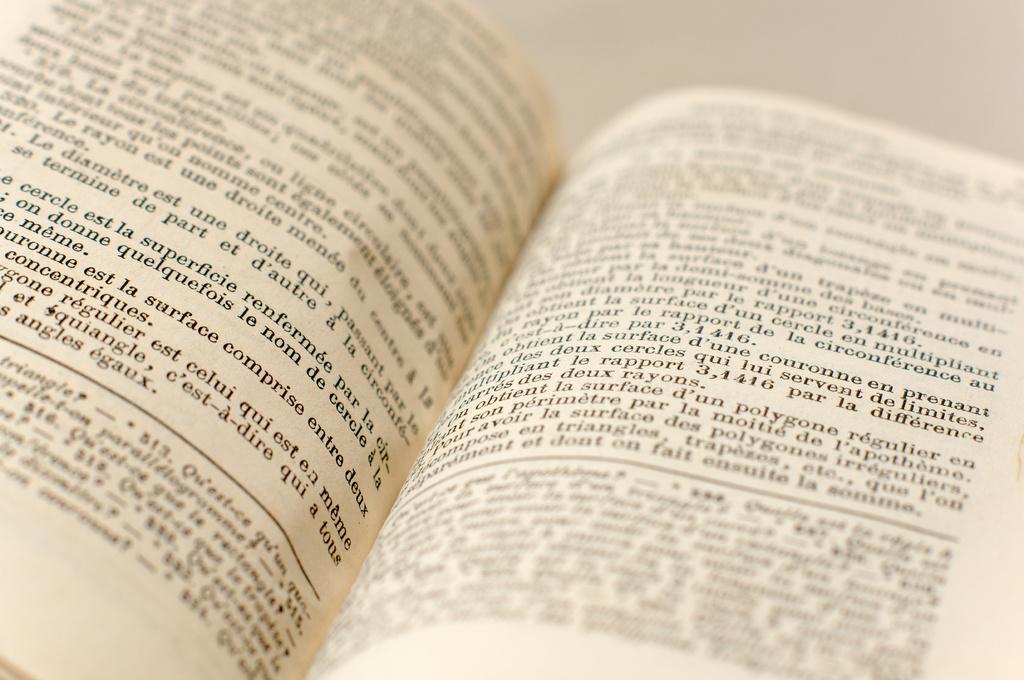What is in that book?
Your response must be concise. Unanswerable. 